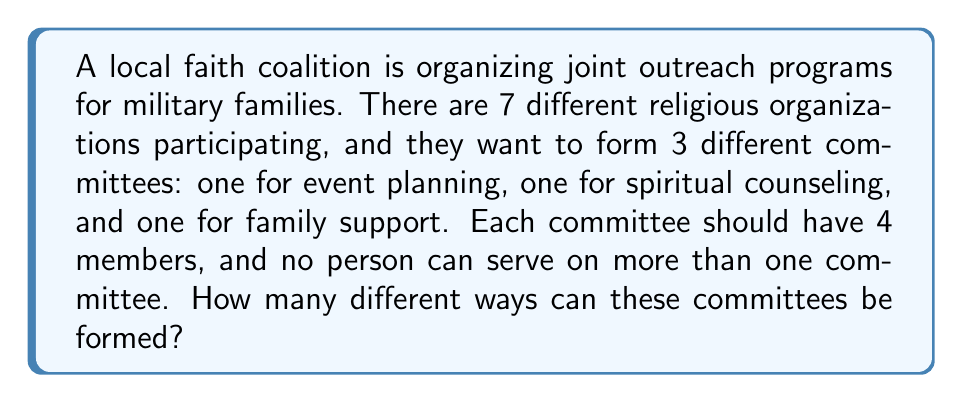Teach me how to tackle this problem. Let's approach this step-by-step:

1) We need to select members for three different committees, each with 4 members, from a pool of 7 organizations.

2) This is a combination problem, as the order within each committee doesn't matter.

3) For the first committee (event planning), we need to choose 4 organizations out of 7. This can be done in $\binom{7}{4}$ ways.

4) After forming the first committee, we have 3 organizations left, and we need to choose all 3 for the second committee (spiritual counseling). This can be done in only $\binom{3}{3} = 1$ way.

5) For the third committee (family support), we have no choice left as we must use the remaining 4 organizations. This can be done in $\binom{4}{4} = 1$ way.

6) By the multiplication principle, the total number of ways to form these committees is:

   $$\binom{7}{4} \cdot \binom{3}{3} \cdot \binom{4}{4}$$

7) Let's calculate:
   $$\binom{7}{4} = \frac{7!}{4!(7-4)!} = \frac{7!}{4!3!} = 35$$

   $$\binom{3}{3} = 1$$
   
   $$\binom{4}{4} = 1$$

8) Therefore, the total number of ways is:
   $$35 \cdot 1 \cdot 1 = 35$$
Answer: The committees can be formed in 35 different ways. 